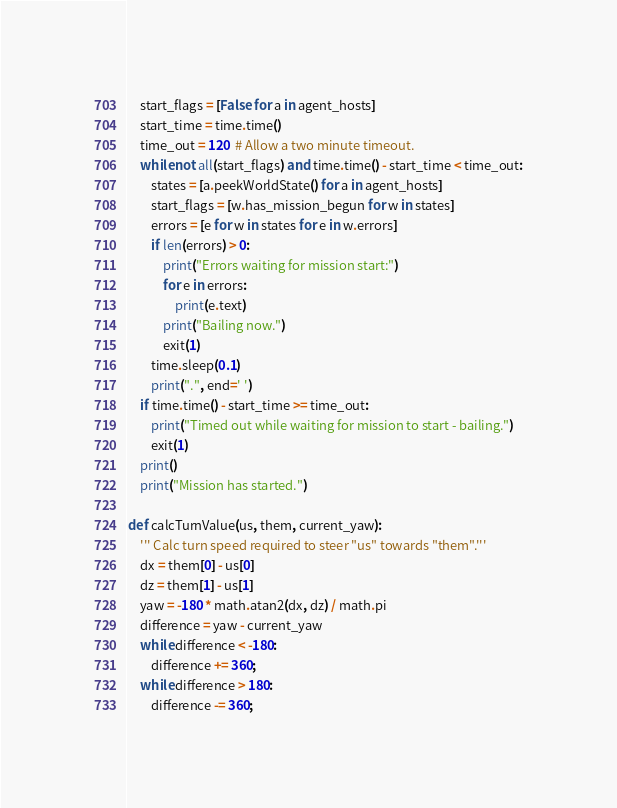<code> <loc_0><loc_0><loc_500><loc_500><_Python_>    start_flags = [False for a in agent_hosts]
    start_time = time.time()
    time_out = 120  # Allow a two minute timeout.
    while not all(start_flags) and time.time() - start_time < time_out:
        states = [a.peekWorldState() for a in agent_hosts]
        start_flags = [w.has_mission_begun for w in states]
        errors = [e for w in states for e in w.errors]
        if len(errors) > 0:
            print("Errors waiting for mission start:")
            for e in errors:
                print(e.text)
            print("Bailing now.")
            exit(1)
        time.sleep(0.1)
        print(".", end=' ')
    if time.time() - start_time >= time_out:
        print("Timed out while waiting for mission to start - bailing.")
        exit(1)
    print()
    print("Mission has started.")

def calcTurnValue(us, them, current_yaw):
    ''' Calc turn speed required to steer "us" towards "them".'''
    dx = them[0] - us[0]
    dz = them[1] - us[1]
    yaw = -180 * math.atan2(dx, dz) / math.pi
    difference = yaw - current_yaw
    while difference < -180:
        difference += 360;
    while difference > 180:
        difference -= 360;</code> 